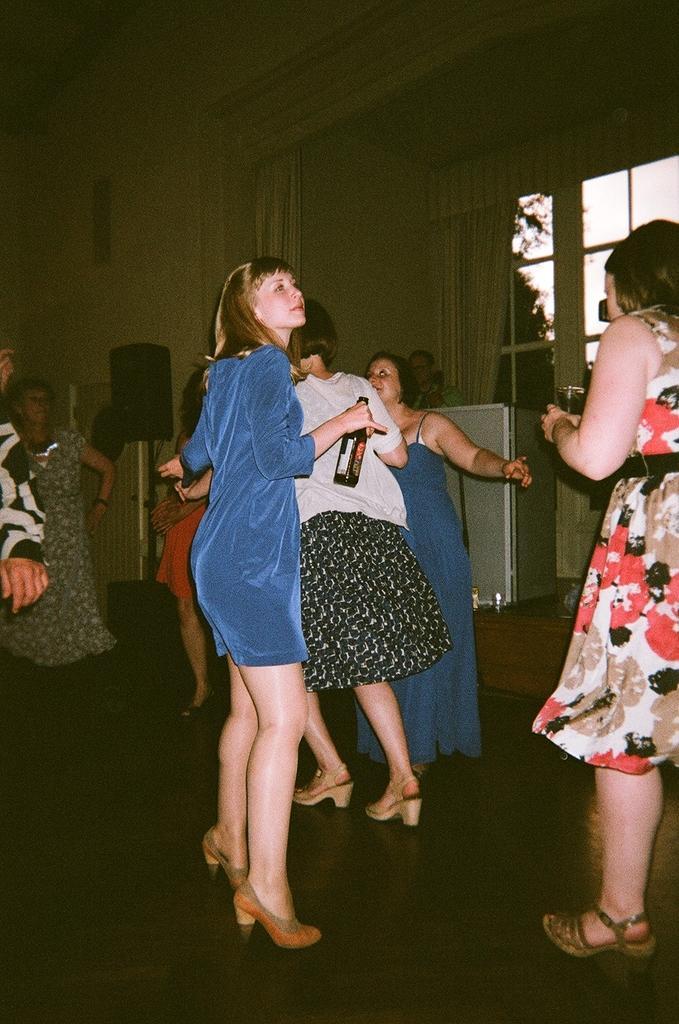Please provide a concise description of this image. In this image, we can see people and one of them is holding a bottle. On the right, there is a lady holding a glass with drink. In the background, there are curtains and we can see some objects and windows, through the glass we can see trees. 